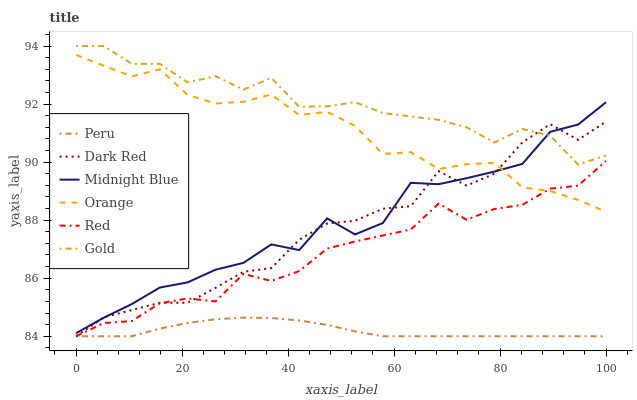Does Peru have the minimum area under the curve?
Answer yes or no. Yes. Does Gold have the maximum area under the curve?
Answer yes or no. Yes. Does Dark Red have the minimum area under the curve?
Answer yes or no. No. Does Dark Red have the maximum area under the curve?
Answer yes or no. No. Is Peru the smoothest?
Answer yes or no. Yes. Is Gold the roughest?
Answer yes or no. Yes. Is Dark Red the smoothest?
Answer yes or no. No. Is Dark Red the roughest?
Answer yes or no. No. Does Dark Red have the lowest value?
Answer yes or no. Yes. Does Gold have the lowest value?
Answer yes or no. No. Does Gold have the highest value?
Answer yes or no. Yes. Does Dark Red have the highest value?
Answer yes or no. No. Is Peru less than Gold?
Answer yes or no. Yes. Is Gold greater than Red?
Answer yes or no. Yes. Does Red intersect Dark Red?
Answer yes or no. Yes. Is Red less than Dark Red?
Answer yes or no. No. Is Red greater than Dark Red?
Answer yes or no. No. Does Peru intersect Gold?
Answer yes or no. No. 